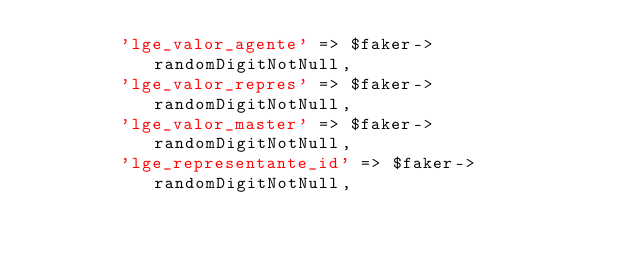Convert code to text. <code><loc_0><loc_0><loc_500><loc_500><_PHP_>        'lge_valor_agente' => $faker->randomDigitNotNull,
        'lge_valor_repres' => $faker->randomDigitNotNull,
        'lge_valor_master' => $faker->randomDigitNotNull,
        'lge_representante_id' => $faker->randomDigitNotNull,</code> 